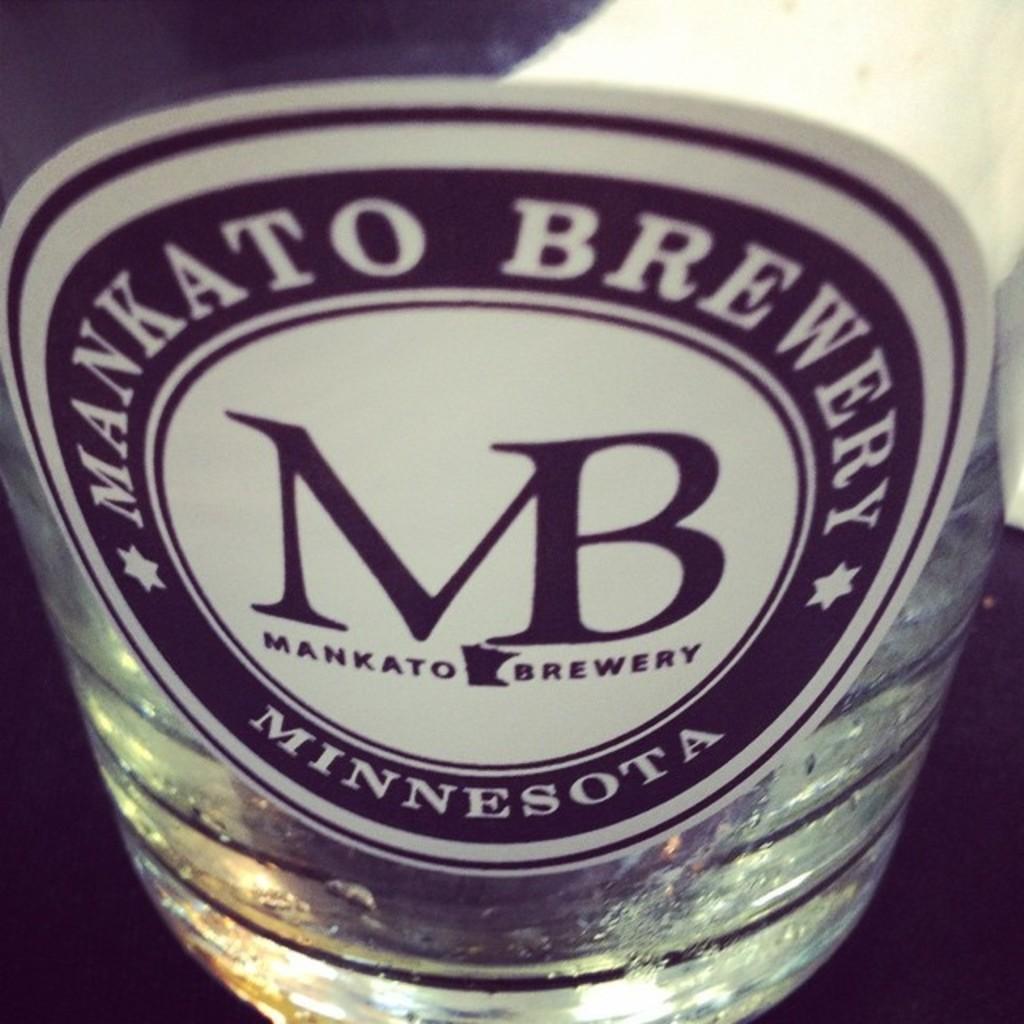What state is this brewery located in?
Keep it short and to the point. Minnesota. 